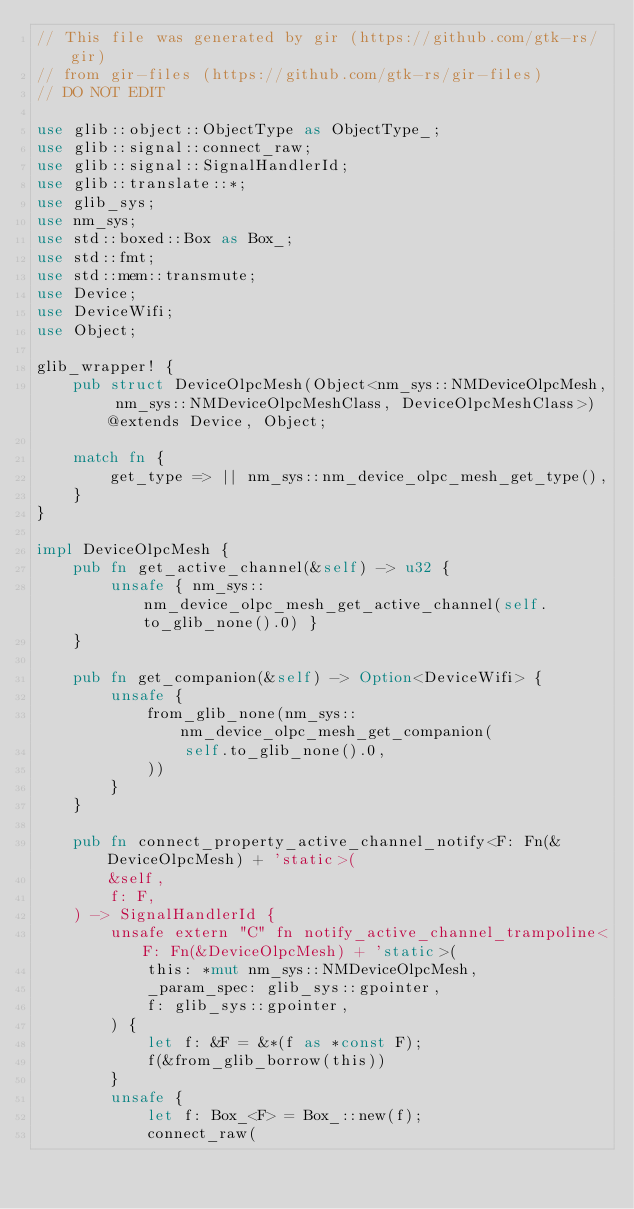<code> <loc_0><loc_0><loc_500><loc_500><_Rust_>// This file was generated by gir (https://github.com/gtk-rs/gir)
// from gir-files (https://github.com/gtk-rs/gir-files)
// DO NOT EDIT

use glib::object::ObjectType as ObjectType_;
use glib::signal::connect_raw;
use glib::signal::SignalHandlerId;
use glib::translate::*;
use glib_sys;
use nm_sys;
use std::boxed::Box as Box_;
use std::fmt;
use std::mem::transmute;
use Device;
use DeviceWifi;
use Object;

glib_wrapper! {
    pub struct DeviceOlpcMesh(Object<nm_sys::NMDeviceOlpcMesh, nm_sys::NMDeviceOlpcMeshClass, DeviceOlpcMeshClass>) @extends Device, Object;

    match fn {
        get_type => || nm_sys::nm_device_olpc_mesh_get_type(),
    }
}

impl DeviceOlpcMesh {
    pub fn get_active_channel(&self) -> u32 {
        unsafe { nm_sys::nm_device_olpc_mesh_get_active_channel(self.to_glib_none().0) }
    }

    pub fn get_companion(&self) -> Option<DeviceWifi> {
        unsafe {
            from_glib_none(nm_sys::nm_device_olpc_mesh_get_companion(
                self.to_glib_none().0,
            ))
        }
    }

    pub fn connect_property_active_channel_notify<F: Fn(&DeviceOlpcMesh) + 'static>(
        &self,
        f: F,
    ) -> SignalHandlerId {
        unsafe extern "C" fn notify_active_channel_trampoline<F: Fn(&DeviceOlpcMesh) + 'static>(
            this: *mut nm_sys::NMDeviceOlpcMesh,
            _param_spec: glib_sys::gpointer,
            f: glib_sys::gpointer,
        ) {
            let f: &F = &*(f as *const F);
            f(&from_glib_borrow(this))
        }
        unsafe {
            let f: Box_<F> = Box_::new(f);
            connect_raw(</code> 